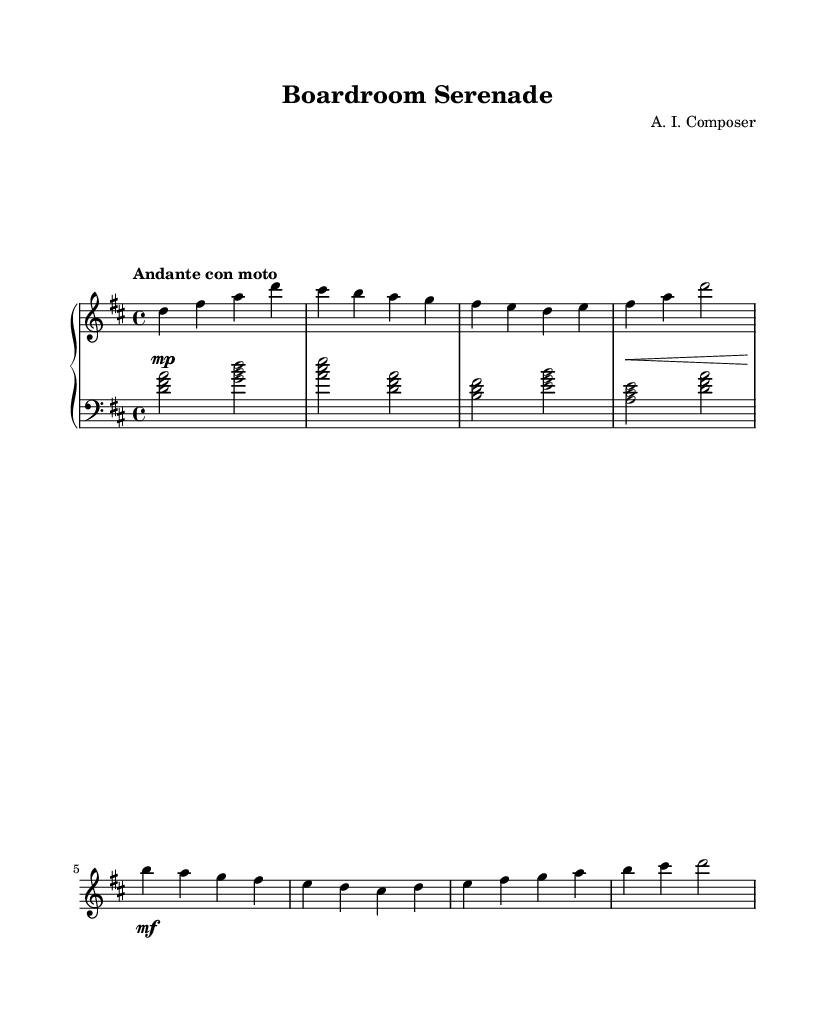What is the key signature of this music? The key signature is D major, which includes two sharps (F# and C#). This can be identified by looking at the key signature at the beginning of the score, which shows these sharps.
Answer: D major What is the time signature of this piece? The time signature is 4/4, indicated at the beginning of the score. This means there are four beats in each measure and the quarter note receives one beat.
Answer: 4/4 What is the tempo marking for this piece? The tempo marking is "Andante con moto," which indicates a moderately slow tempo with some motion. This can be found at the beginning of the score written above the staff.
Answer: Andante con moto How many measures are in the right hand section? There are eight measures in the right hand section, which can be counted directly from the notation on the staff where the right hand part is indicated.
Answer: Eight What is the dynamic marking for the beginning of the piece? The dynamic marking at the beginning is "mp," which stands for mezzo-piano, indicating a moderately soft sound. This marking is shown at the start of the first measure in the dynamics line.
Answer: mezzo-piano Explain the relationship between the main theme and the secondary theme in terms of key signature. The main theme starts in the key of D major, while the secondary theme also stays in D major. This can be inferred by analyzing the notes and chords used in both themes, which do not introduce accidentals that would change the key. Hence, they share the same key.
Answer: D major 